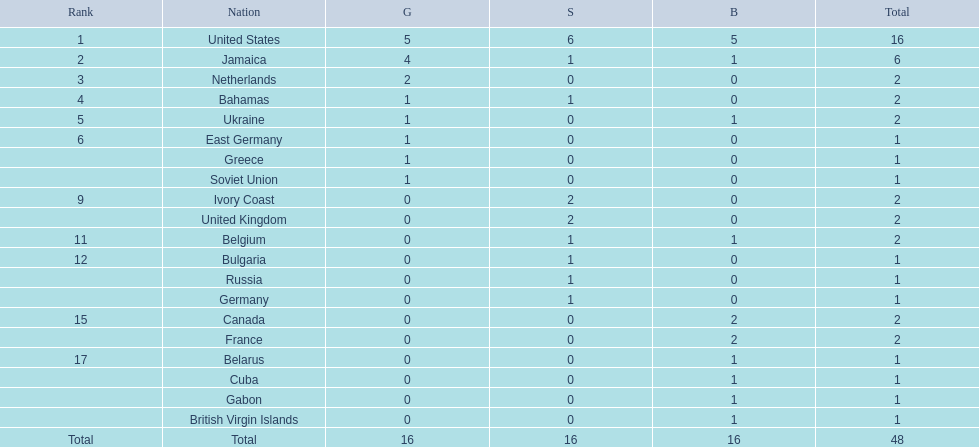How many nations won more than one silver medal? 3. 